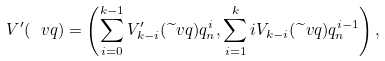<formula> <loc_0><loc_0><loc_500><loc_500>V ^ { \prime } ( \ v q ) = \left ( \sum _ { i = 0 } ^ { k - 1 } V _ { k - i } ^ { \prime } ( \widetilde { \ } v q ) q _ { n } ^ { i } , \sum _ { i = 1 } ^ { k } i V _ { k - i } ( \widetilde { \ } v q ) q _ { n } ^ { i - 1 } \right ) ,</formula> 